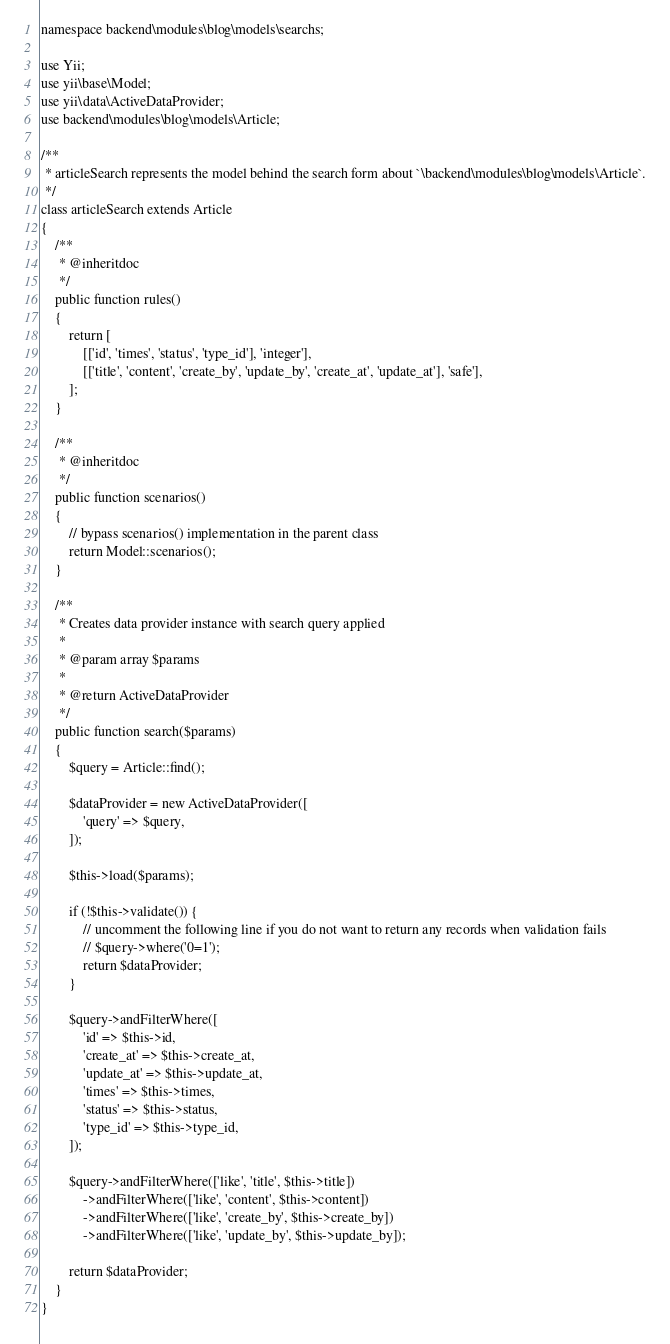Convert code to text. <code><loc_0><loc_0><loc_500><loc_500><_PHP_>namespace backend\modules\blog\models\searchs;

use Yii;
use yii\base\Model;
use yii\data\ActiveDataProvider;
use backend\modules\blog\models\Article;

/**
 * articleSearch represents the model behind the search form about `\backend\modules\blog\models\Article`.
 */
class articleSearch extends Article
{
    /**
     * @inheritdoc
     */
    public function rules()
    {
        return [
            [['id', 'times', 'status', 'type_id'], 'integer'],
            [['title', 'content', 'create_by', 'update_by', 'create_at', 'update_at'], 'safe'],
        ];
    }

    /**
     * @inheritdoc
     */
    public function scenarios()
    {
        // bypass scenarios() implementation in the parent class
        return Model::scenarios();
    }

    /**
     * Creates data provider instance with search query applied
     *
     * @param array $params
     *
     * @return ActiveDataProvider
     */
    public function search($params)
    {
        $query = Article::find();

        $dataProvider = new ActiveDataProvider([
            'query' => $query,
        ]);

        $this->load($params);

        if (!$this->validate()) {
            // uncomment the following line if you do not want to return any records when validation fails
            // $query->where('0=1');
            return $dataProvider;
        }

        $query->andFilterWhere([
            'id' => $this->id,
            'create_at' => $this->create_at,
            'update_at' => $this->update_at,
            'times' => $this->times,
            'status' => $this->status,
            'type_id' => $this->type_id,
        ]);

        $query->andFilterWhere(['like', 'title', $this->title])
            ->andFilterWhere(['like', 'content', $this->content])
            ->andFilterWhere(['like', 'create_by', $this->create_by])
            ->andFilterWhere(['like', 'update_by', $this->update_by]);

        return $dataProvider;
    }
}
</code> 